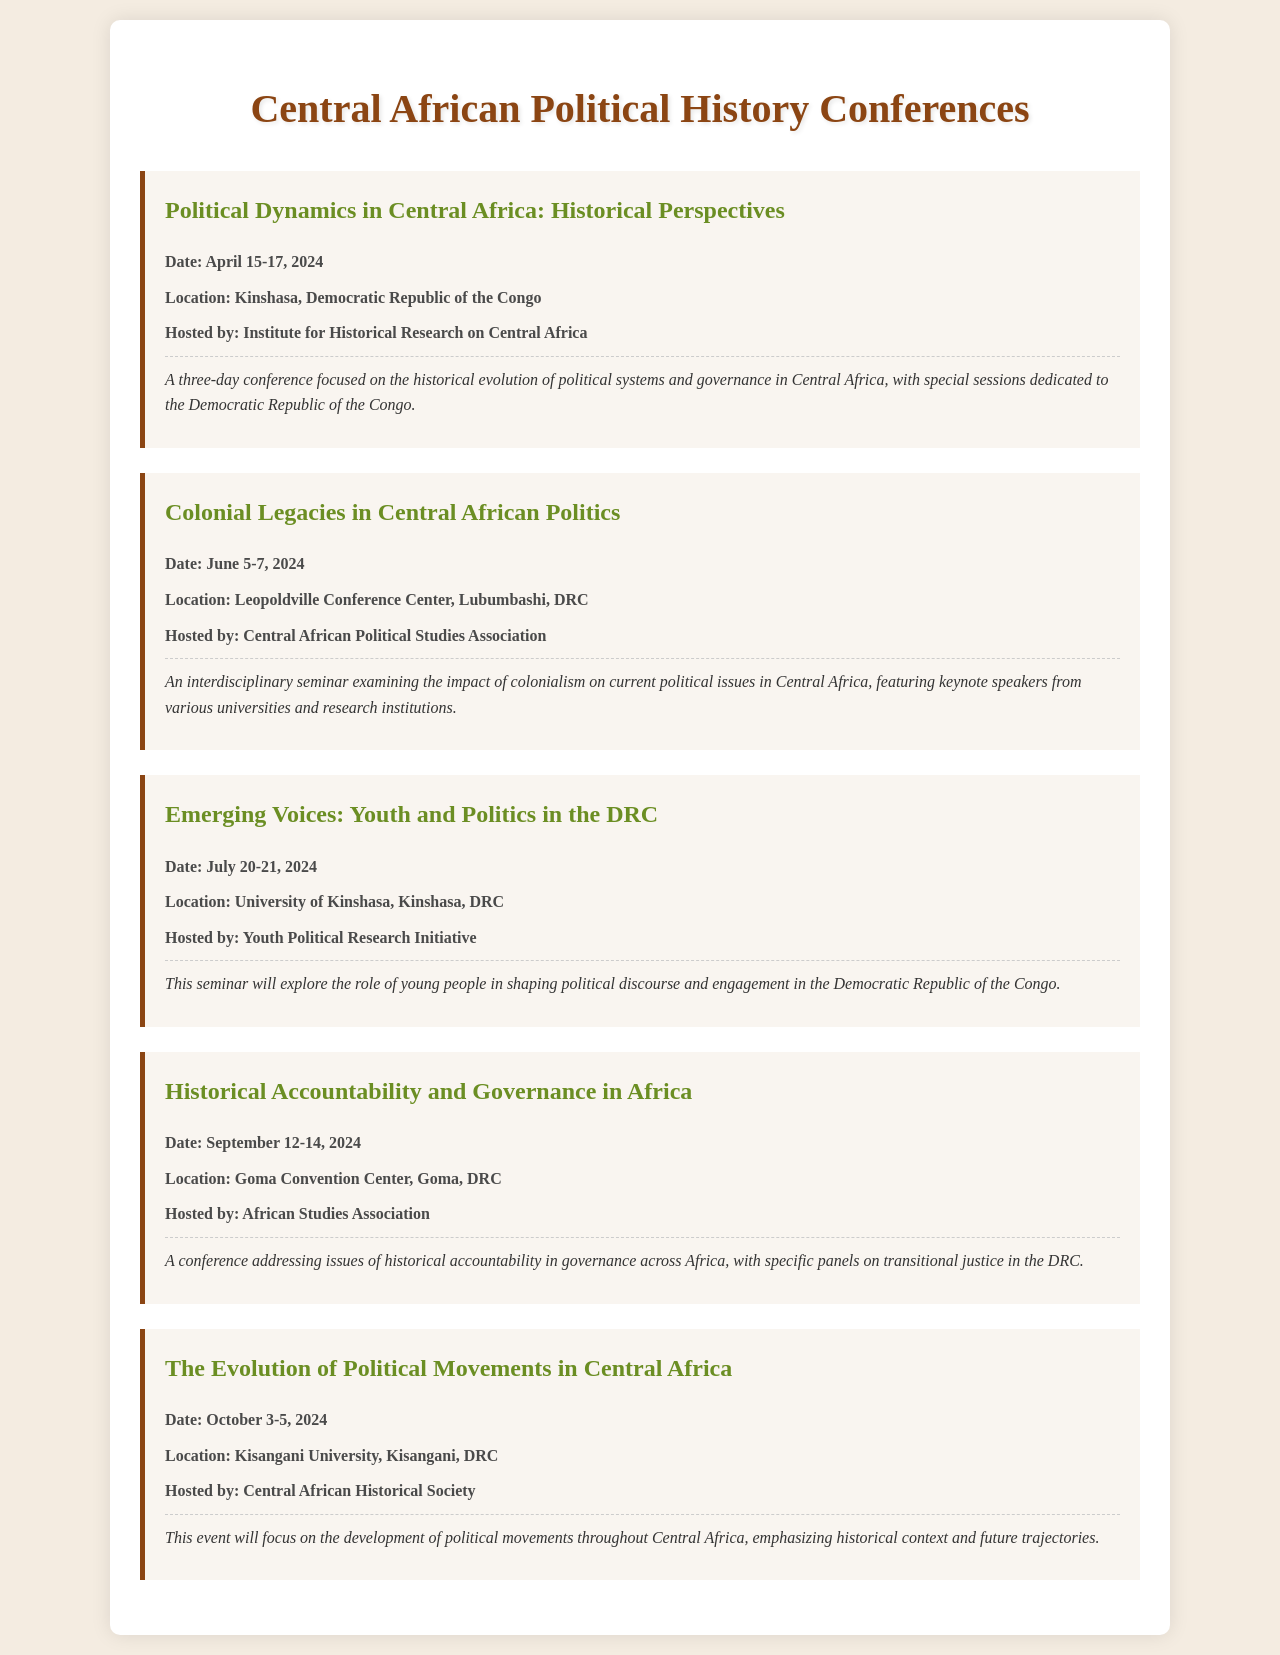What is the title of the first conference? The title of the first conference is listed at the beginning of its section in the document.
Answer: Political Dynamics in Central Africa: Historical Perspectives When is the Colonial Legacies seminar scheduled? The date for the Colonial Legacies seminar is mentioned directly in its section.
Answer: June 5-7, 2024 Where is the Emerging Voices seminar taking place? The location for the Emerging Voices seminar is provided in the location paragraph of its section.
Answer: University of Kinshasa, Kinshasa, DRC Who is hosting the Historical Accountability and Governance conference? The hosting organization is specified in the hosted by paragraph within that conference's section.
Answer: African Studies Association How many days will the Political Dynamics conference last? The duration is indicated by the date range provided in the conference details.
Answer: Three days What is the focus of the Emerging Voices seminar? The main topic is highlighted in the description paragraph for that seminar.
Answer: The role of young people in shaping political discourse Which conference discusses transitional justice in the DRC? The conference's focus on transitional justice is mentioned in its description paragraph.
Answer: Historical Accountability and Governance in Africa What is a common theme among all events listed? All events address aspects of political history and governance in Central Africa, as can be deduced from the titles and descriptions.
Answer: Political history and governance Where will the Evolution of Political Movements conference be held? The location is directly mentioned in the location paragraph of the respective conference section.
Answer: Kisangani University, Kisangani, DRC 